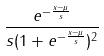Convert formula to latex. <formula><loc_0><loc_0><loc_500><loc_500>\frac { e ^ { - \frac { x - \mu } { s } } } { s ( 1 + e ^ { - \frac { x - \mu } { s } } ) ^ { 2 } }</formula> 